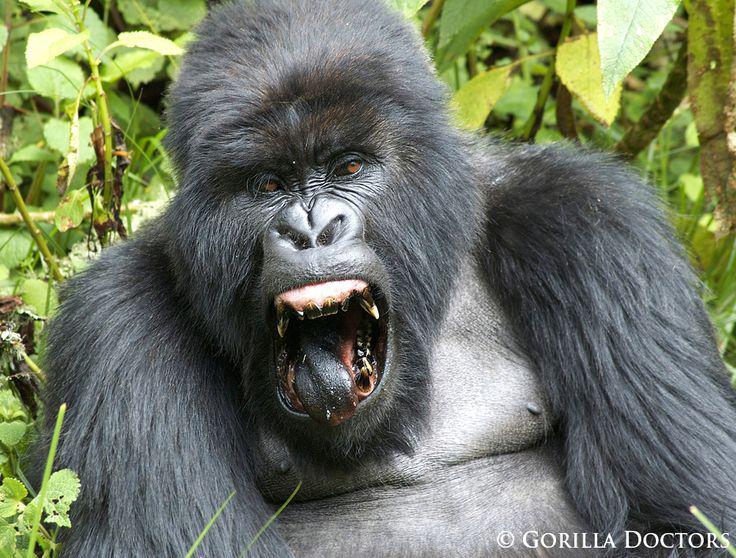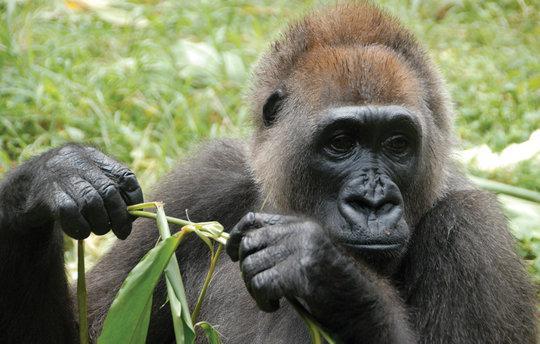The first image is the image on the left, the second image is the image on the right. Considering the images on both sides, is "the left and right image contains the same number of gorillas." valid? Answer yes or no. Yes. The first image is the image on the left, the second image is the image on the right. Given the left and right images, does the statement "The combined images include exactly two baby gorillas with fuzzy black fur and at least one adult." hold true? Answer yes or no. No. 